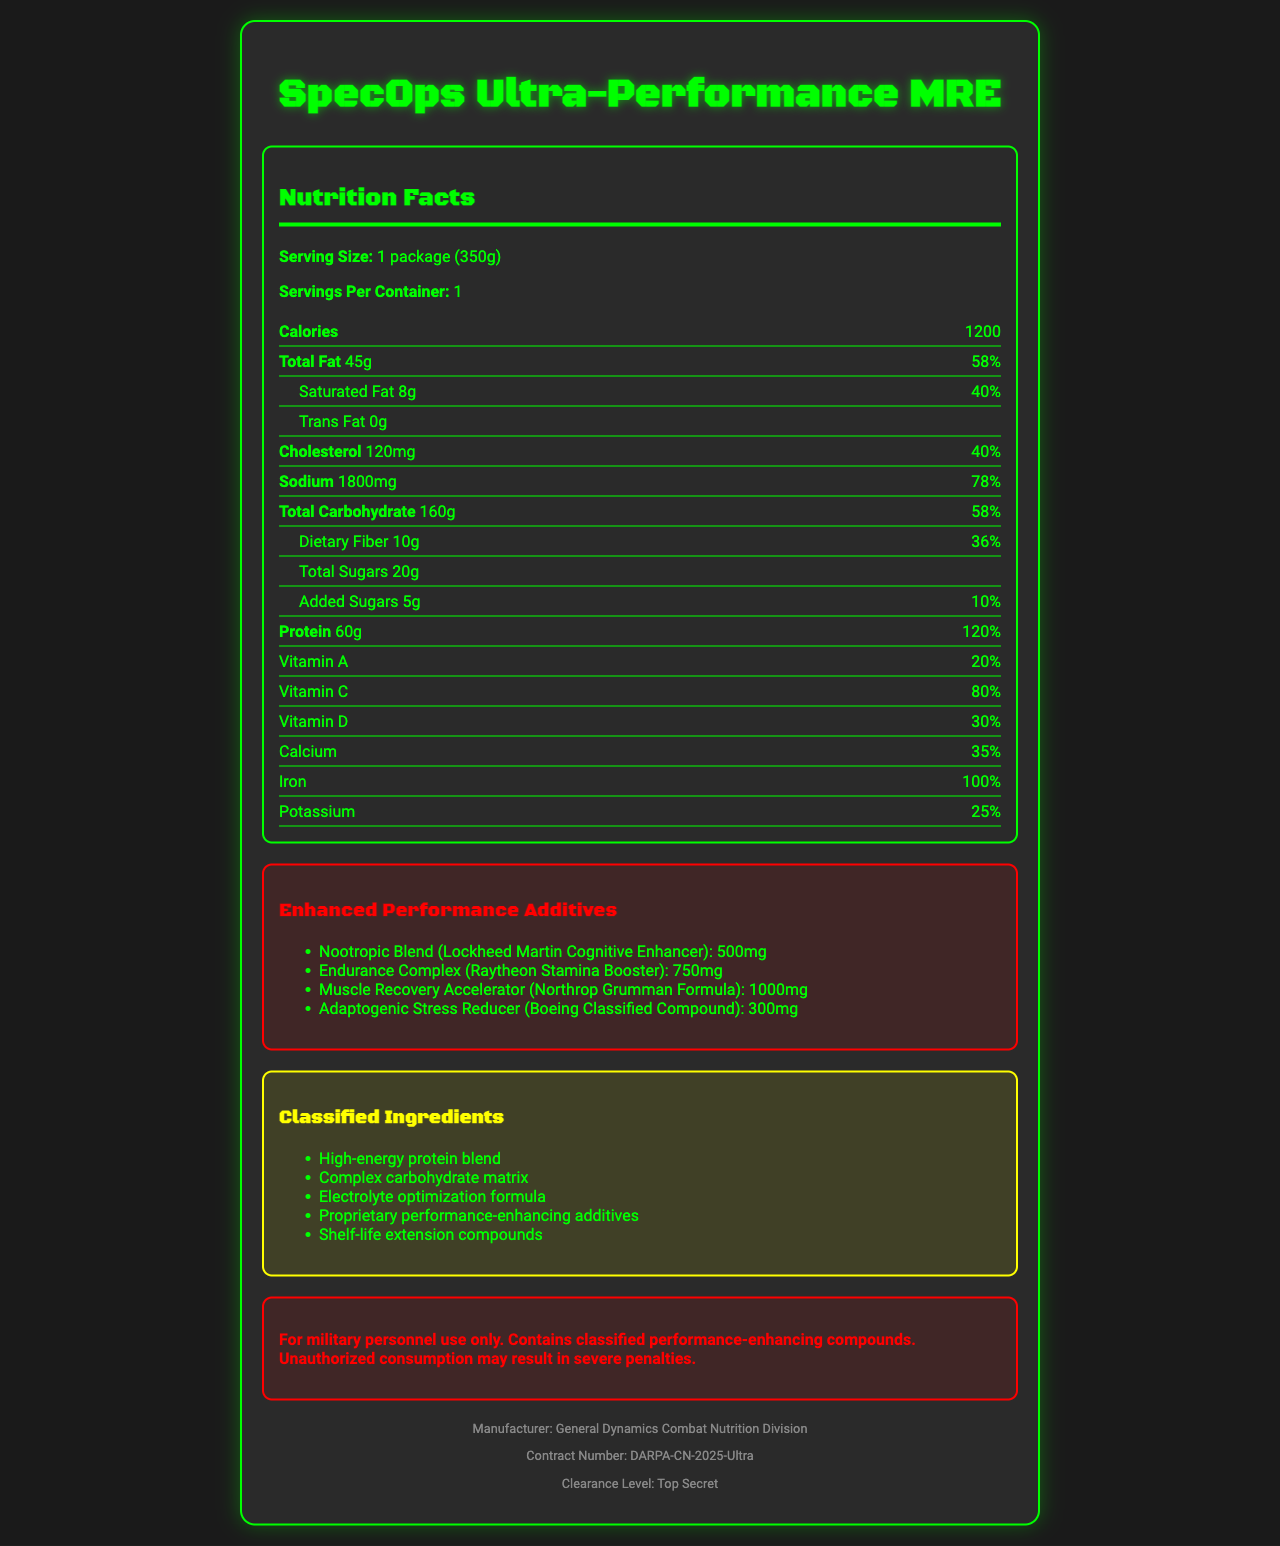What is the serving size of the SpecOps Ultra-Performance MRE? The serving size is directly stated as "1 package (350g)" in the Nutrition Facts section.
Answer: 1 package (350g) How many calories are in one package of the MRE? The calories per package are listed as 1200 on the Nutrition Facts section.
Answer: 1200 What percentage of the daily value of saturated fat does this MRE contain? The amount of saturated fat is 8g, which is 40% of the daily value, as shown in the Nutrition Facts section.
Answer: 40% How much sodium does the MRE contain? The sodium content is listed as 1800mg in the document.
Answer: 1800mg How much protein is in the SpecOps Ultra-Performance MRE? The protein amount is stated as 60g in the Nutrition Facts section.
Answer: 60g What is included under "Enhanced Performance Additives"? 
A. Caffeine Mix 
B. Nootropic Blend 
C. Muscle Recovery Accelerator 
D. Both B and C The enhanced performance additives include Nootropic Blend (Lockheed Martin Cognitive Enhancer) and Muscle Recovery Accelerator (Northrop Grumman Formula), as listed in the document.
Answer: D The SpecOps Ultra-Performance MRE is manufactured by?
A. Raytheon
B. Northrop Grumman
C. General Dynamics Combat Nutrition Division
D. Lockheed Martin The manufacturer is stated as General Dynamics Combat Nutrition Division in the footer of the document.
Answer: C Does this MRE contain any added sugars? The document shows that this MRE contains 5g of added sugars, which is 10% of the daily value.
Answer: Yes Does the enhanced performance additives section include a compound called "Adaptogenic Stress Reducer"? The document lists "Adaptogenic Stress Reducer (Boeing Classified Compound)" under enhanced performance additives.
Answer: Yes Describe the main idea of the document. The document provides comprehensive details on the nutritional composition and specialized additives designed for enhanced performance, emphasizing its restricted military use.
Answer: The document is a Nutrition Facts label for a classified military MRE called SpecOps Ultra-Performance MRE. It outlines the serving size, nutritional content, and special performance-enhancing additives along with classified ingredients. It also includes a warning about unauthorized use and mentions the manufacturer as General Dynamics Combat Nutrition Division. What are the three classified ingredients listed in the document? The document does not specify the actual substances or components of the classified ingredients; it just lists their general names.
Answer: Not enough information What is the percentage of daily value for Iron in this MRE? The Nutrition Facts section states that the iron content is 100% of the daily value.
Answer: 100% How many grams of dietary fiber are in each package of the MRE? The dietary fiber amount is stated as 10g in the Nutrition Facts section.
Answer: 10g What is the contract number associated with this product? The contract number is mentioned in the footer of the document.
Answer: DARPA-CN-2025-Ultra Which company is associated with providing the Nootropic Blend additive? The Nootropic Blend is identified as a "Lockheed Martin Cognitive Enhancer" under the Enhanced Performance Additives section.
Answer: Lockheed Martin 